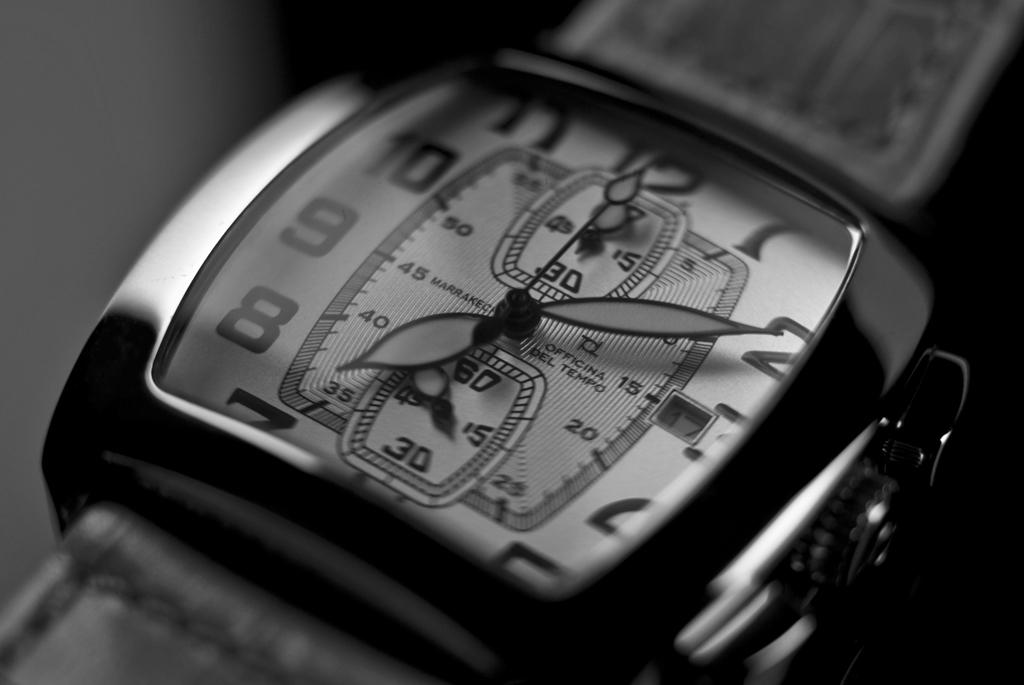What object is the main subject of the image? There is a wrist watch in the image. Can you describe the colors of the wrist watch? The wrist watch is black and grey in color. What can be seen in the background of the image? The background of the image is black and blurry. Where is the pot located in the image? There is no pot present in the image. What type of waste can be seen in the image? There is no waste visible in the image; it features a wrist watch and a blurry background. 